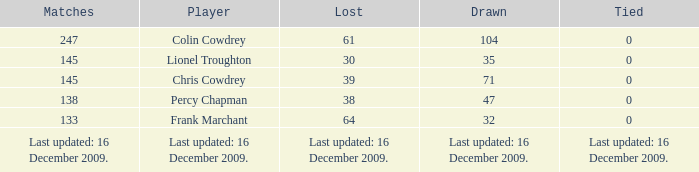Can you tell me the tie for a 47 draw? 0.0. 